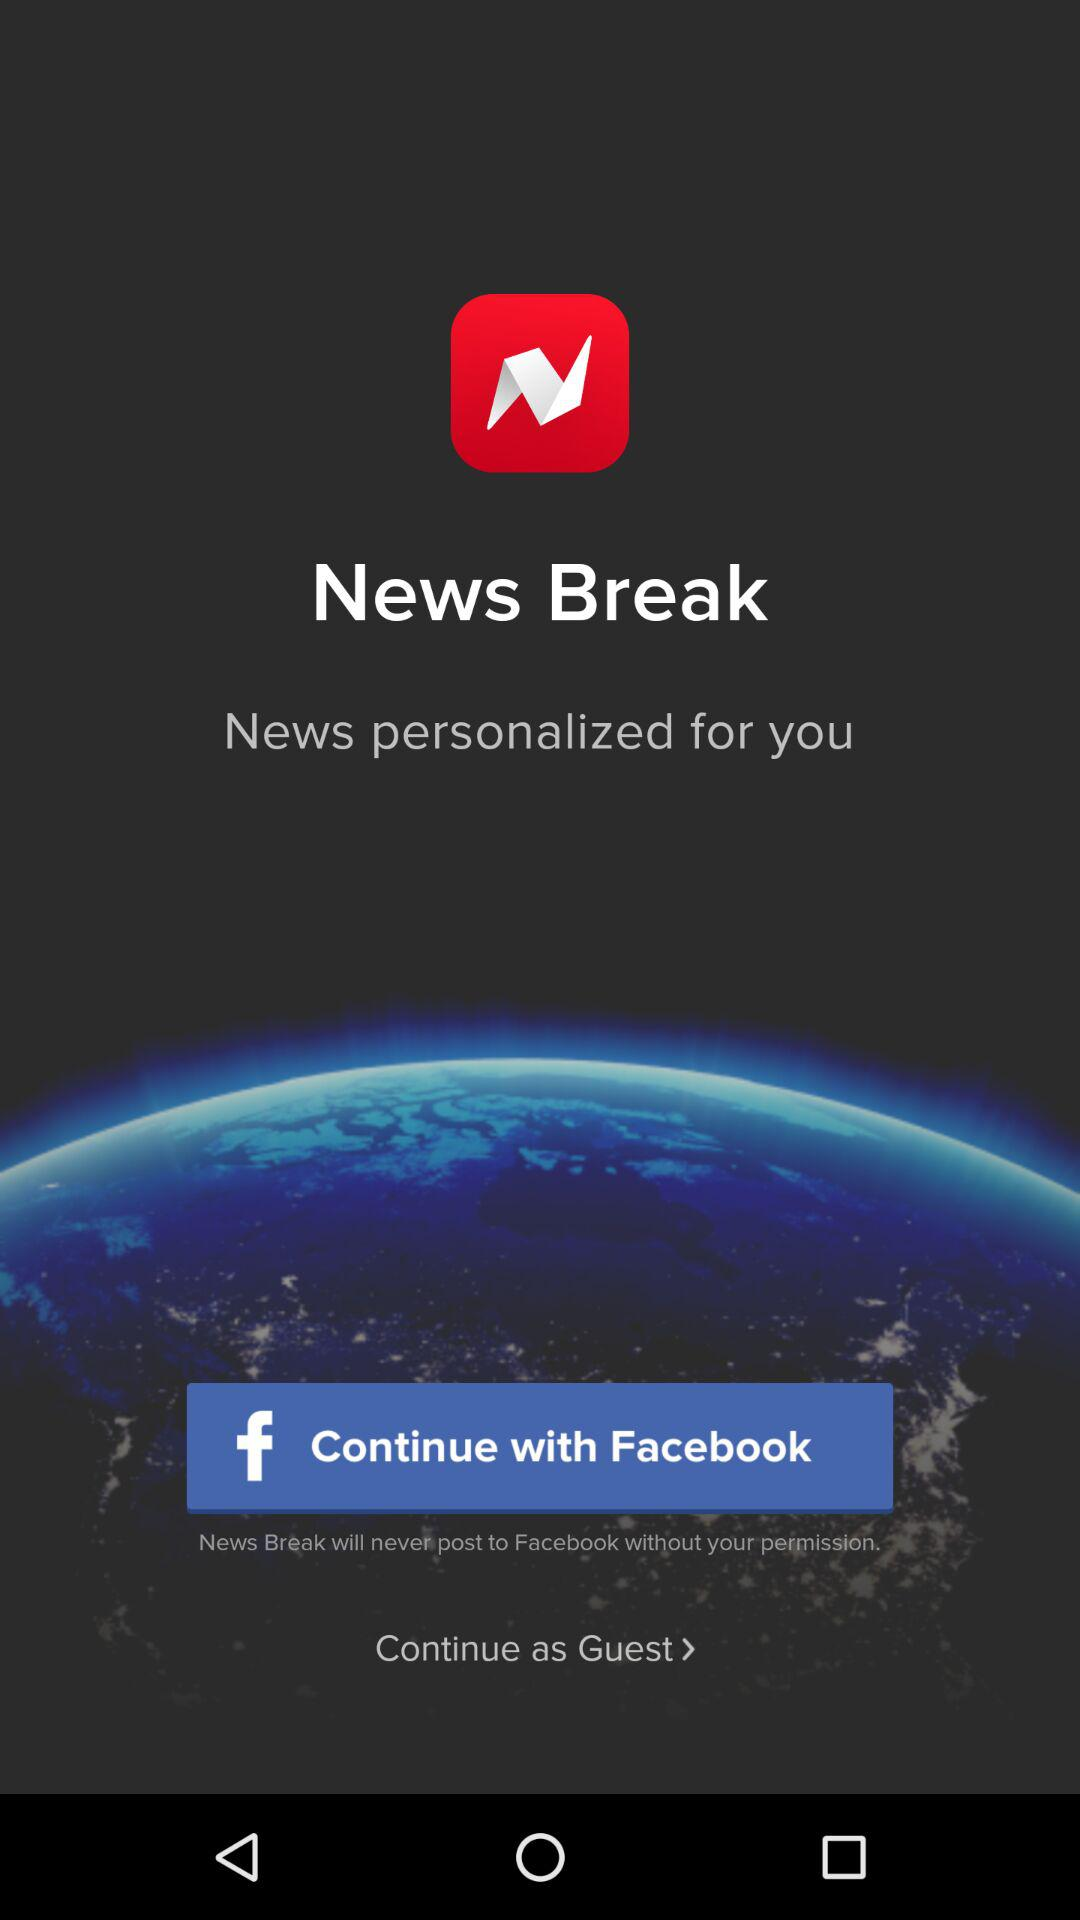What is the application name? The application name is "News Break". 